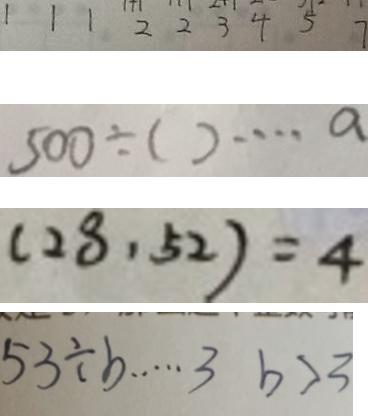Convert formula to latex. <formula><loc_0><loc_0><loc_500><loc_500>1 1 1 2 2 3 4 5 7 
 5 0 0 \div ( ) \cdots a 
 ( 2 8 , 5 2 ) = 4 
 5 3 \div b \cdots 3 b > 3</formula> 